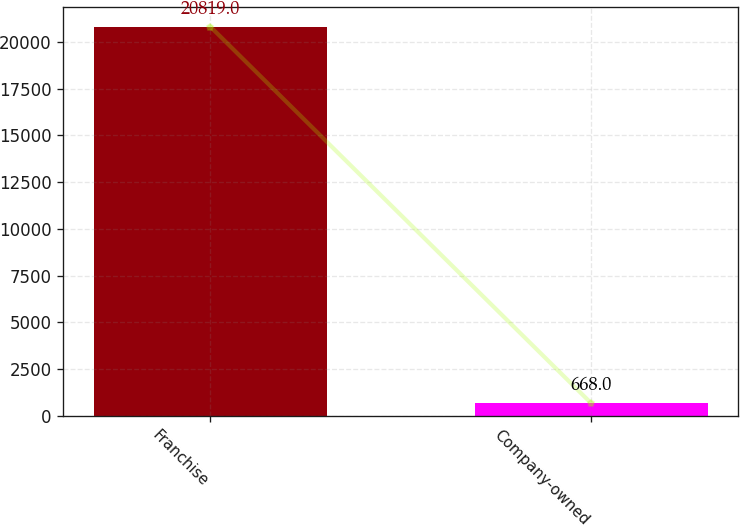Convert chart. <chart><loc_0><loc_0><loc_500><loc_500><bar_chart><fcel>Franchise<fcel>Company-owned<nl><fcel>20819<fcel>668<nl></chart> 